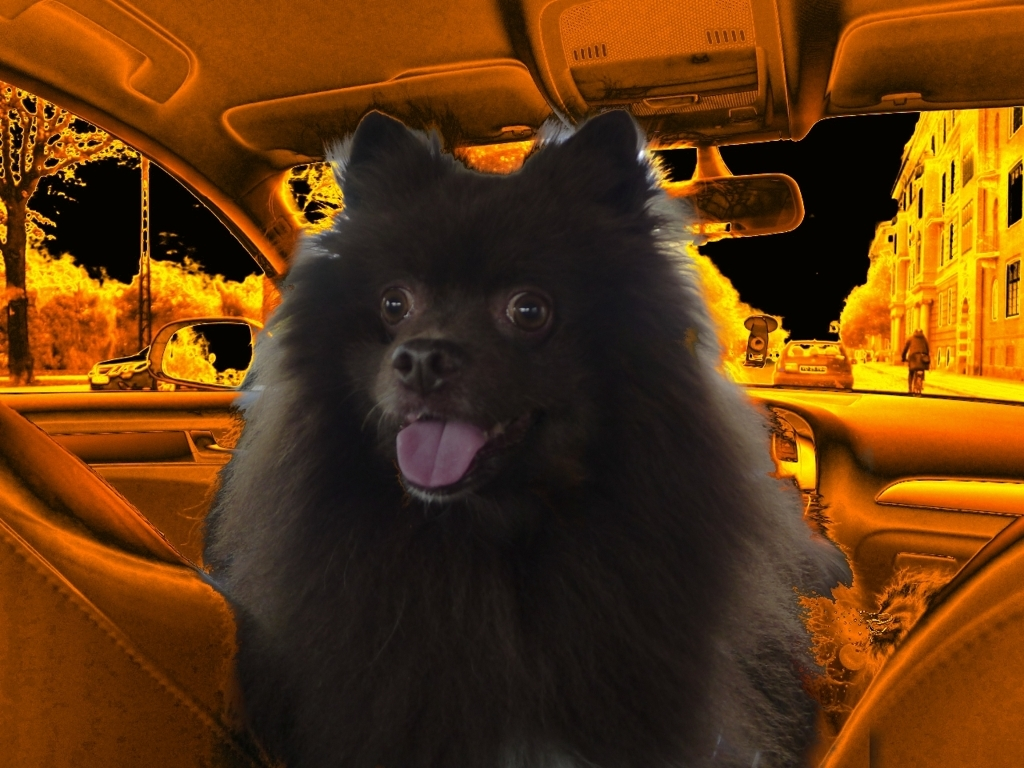Is there anything in this image indicating it might have been edited or manipulated? Yes, there are signs that the image could have been edited. The dog looks notably distinct from the heavily orange-toned background, which implies that it might have been superimposed onto the background. The boundaries around the dog also seem a bit too well-defined, suggesting a potential use of a selection tool in an image-editing software. What could be the purpose of applying such a dramatic filter to this image? The application of a dramatic filter like this one could serve several artistic or practical purposes. Artistically, it creates a striking visual contrast that draws attention to the dog, the main subject, by setting it against an unusual, almost surreal backdrop. Practically, it could be used to conceal flaws in the original image or to create a certain mood or atmosphere that aligns with a specific theme or message the creator wishes to convey. 